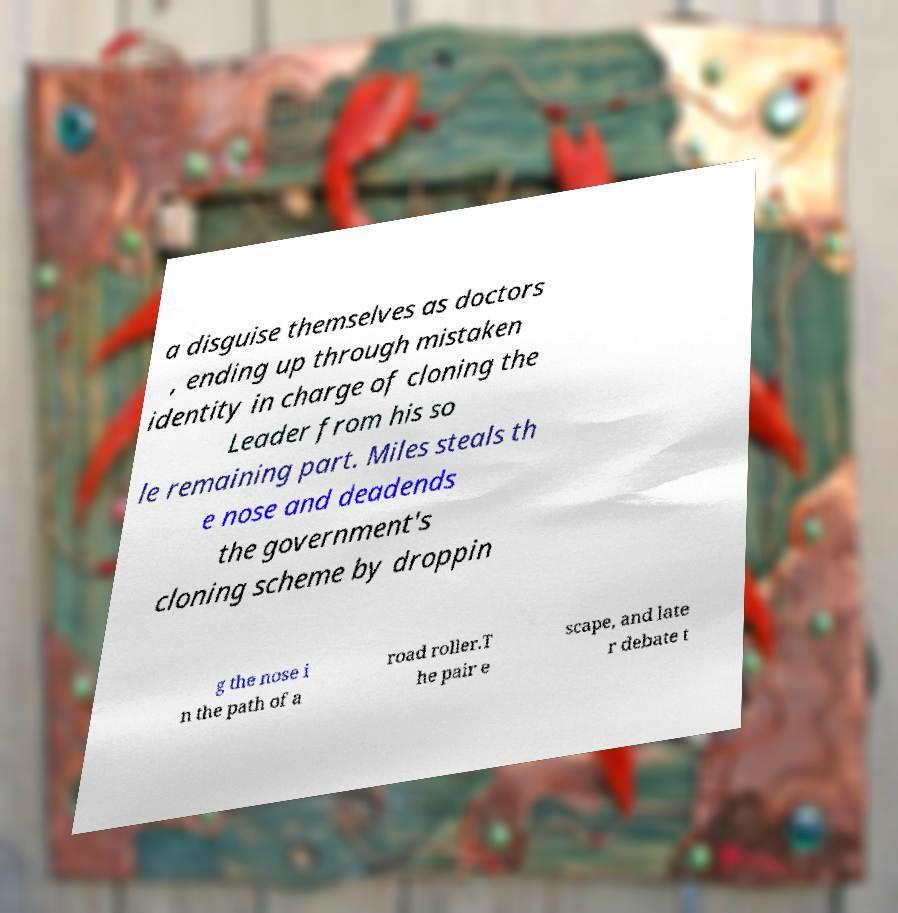What messages or text are displayed in this image? I need them in a readable, typed format. a disguise themselves as doctors , ending up through mistaken identity in charge of cloning the Leader from his so le remaining part. Miles steals th e nose and deadends the government's cloning scheme by droppin g the nose i n the path of a road roller.T he pair e scape, and late r debate t 